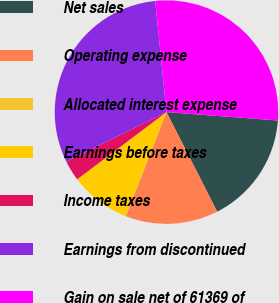Convert chart to OTSL. <chart><loc_0><loc_0><loc_500><loc_500><pie_chart><fcel>Net sales<fcel>Operating expense<fcel>Allocated interest expense<fcel>Earnings before taxes<fcel>Income taxes<fcel>Earnings from discontinued<fcel>Gain on sale net of 61369 of<nl><fcel>16.31%<fcel>13.42%<fcel>0.07%<fcel>8.74%<fcel>2.96%<fcel>30.7%<fcel>27.81%<nl></chart> 